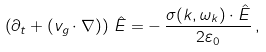<formula> <loc_0><loc_0><loc_500><loc_500>\left ( \partial _ { t } + ( { v } _ { g } \cdot { \nabla } ) \right ) \, { \hat { E } } = - \, \frac { { \sigma } ( { k } , \omega _ { k } ) \cdot { \hat { E } } } { 2 \varepsilon _ { 0 } } \, ,</formula> 